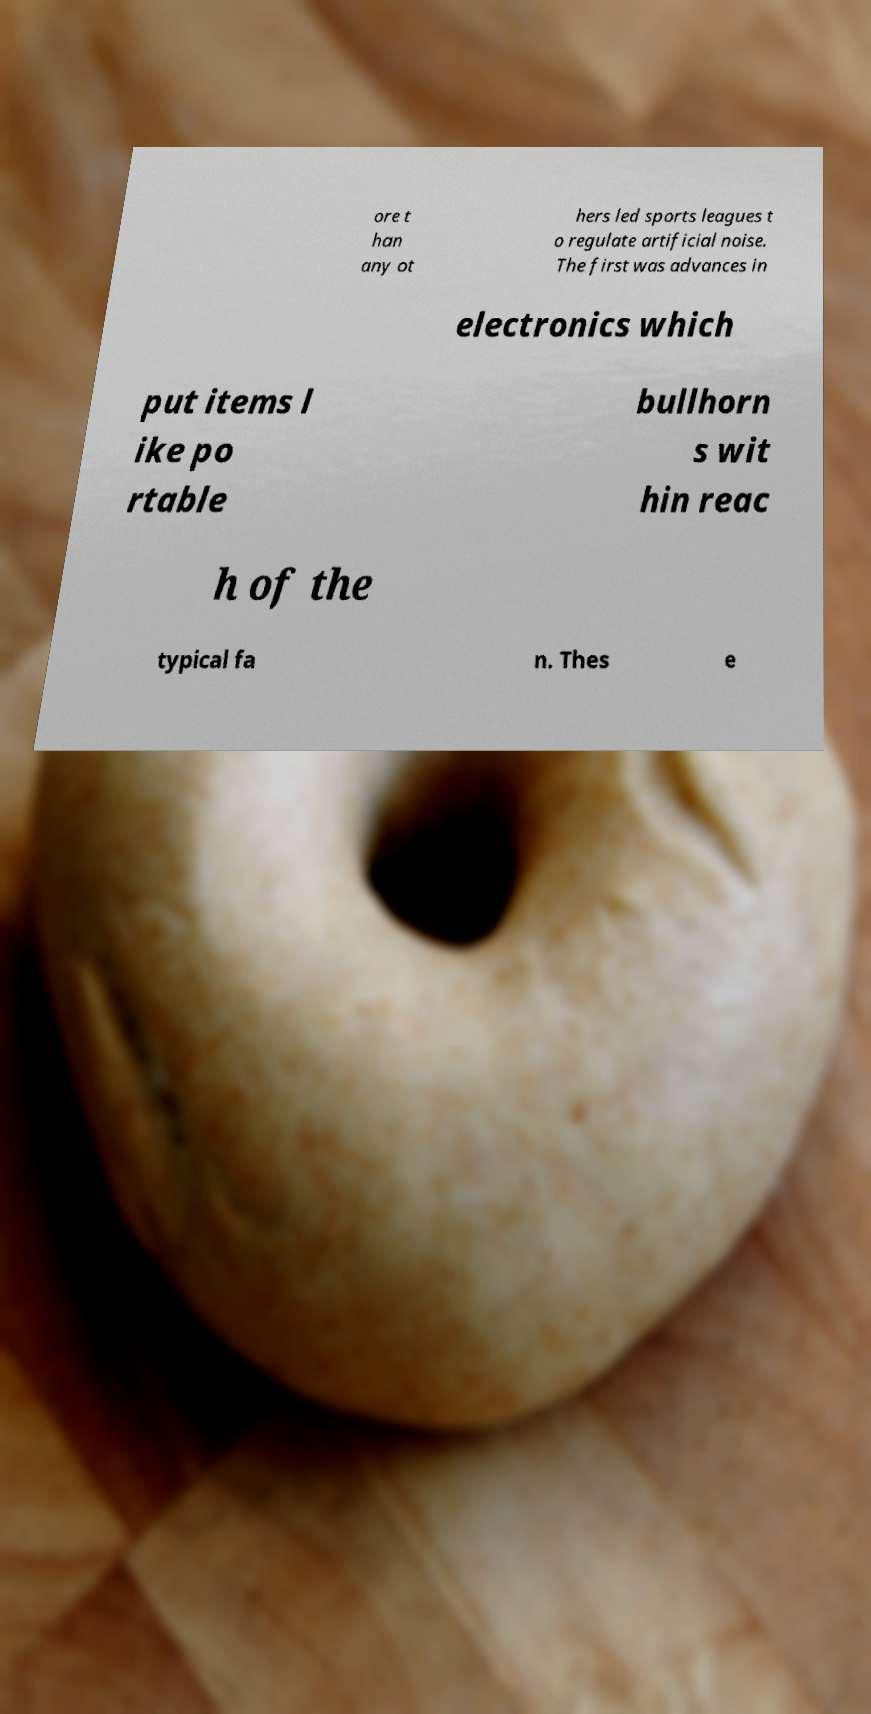Please read and relay the text visible in this image. What does it say? ore t han any ot hers led sports leagues t o regulate artificial noise. The first was advances in electronics which put items l ike po rtable bullhorn s wit hin reac h of the typical fa n. Thes e 